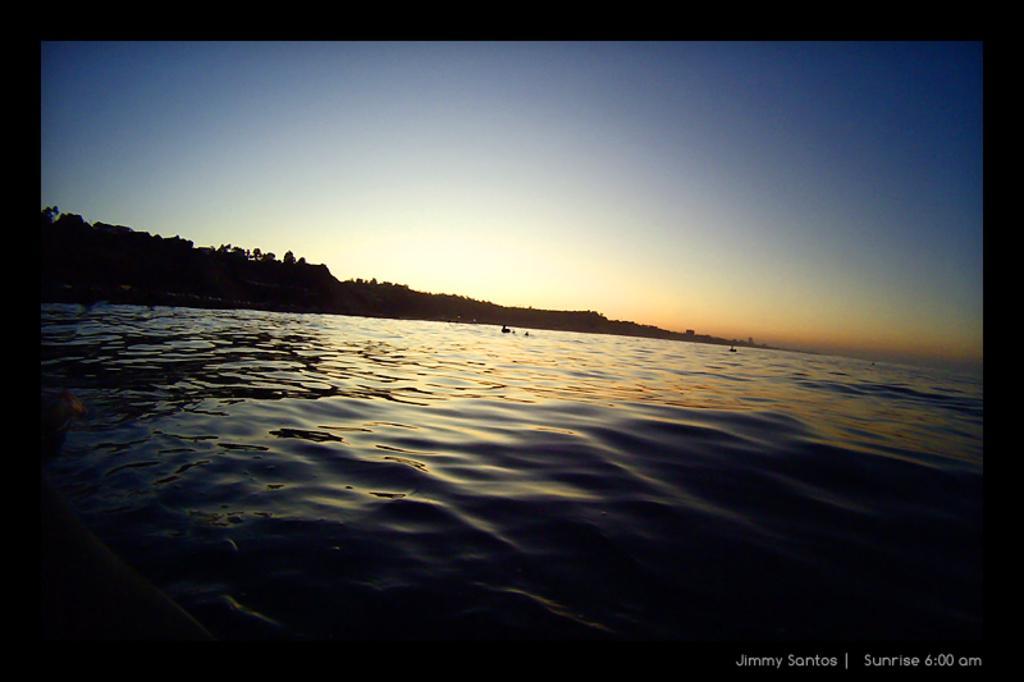How would you summarize this image in a sentence or two? In this picture I can see the water in front and in the background I see the sky. On the bottom right of this picture I see the watermark. 